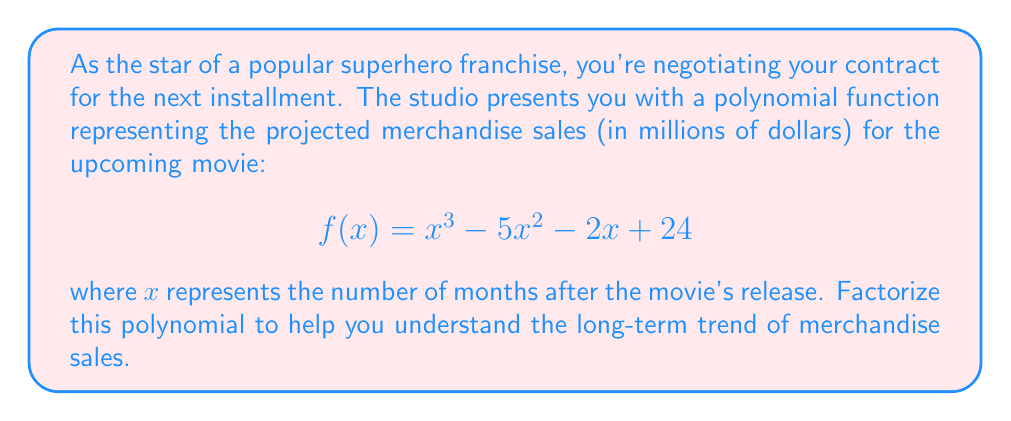What is the answer to this math problem? Let's approach this step-by-step:

1) First, we'll try to identify any factors using the rational root theorem. The possible rational roots are the factors of the constant term, 24: ±1, ±2, ±3, ±4, ±6, ±8, ±12, ±24.

2) Testing these values, we find that f(4) = 0. So (x - 4) is a factor.

3) We can use polynomial long division to divide f(x) by (x - 4):

   $$\frac{x^3 - 5x^2 - 2x + 24}{x - 4} = x^2 - x - 6$$

4) Now we have: f(x) = (x - 4)(x^2 - x - 6)

5) The quadratic factor (x^2 - x - 6) can be factored further:
   
   $$x^2 - x - 6 = (x - 3)(x + 2)$$

6) Therefore, the complete factorization is:

   $$f(x) = (x - 4)(x - 3)(x + 2)$$

This factorization reveals that the merchandise sales function has three roots: 4, 3, and -2. In the context of the movie release, this suggests that sales may have significant changes around 2 months before release (x = -2), 3 months after release, and 4 months after release.
Answer: $$f(x) = (x - 4)(x - 3)(x + 2)$$ 